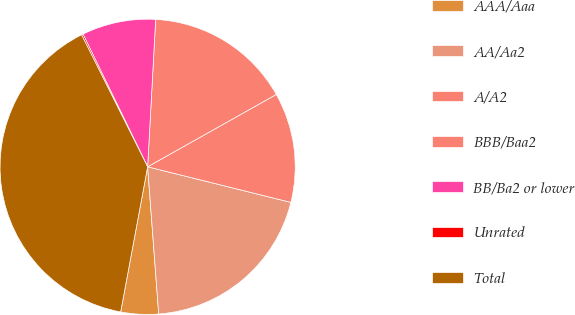Convert chart to OTSL. <chart><loc_0><loc_0><loc_500><loc_500><pie_chart><fcel>AAA/Aaa<fcel>AA/Aa2<fcel>A/A2<fcel>BBB/Baa2<fcel>BB/Ba2 or lower<fcel>Unrated<fcel>Total<nl><fcel>4.12%<fcel>19.93%<fcel>12.03%<fcel>15.98%<fcel>8.08%<fcel>0.17%<fcel>39.69%<nl></chart> 